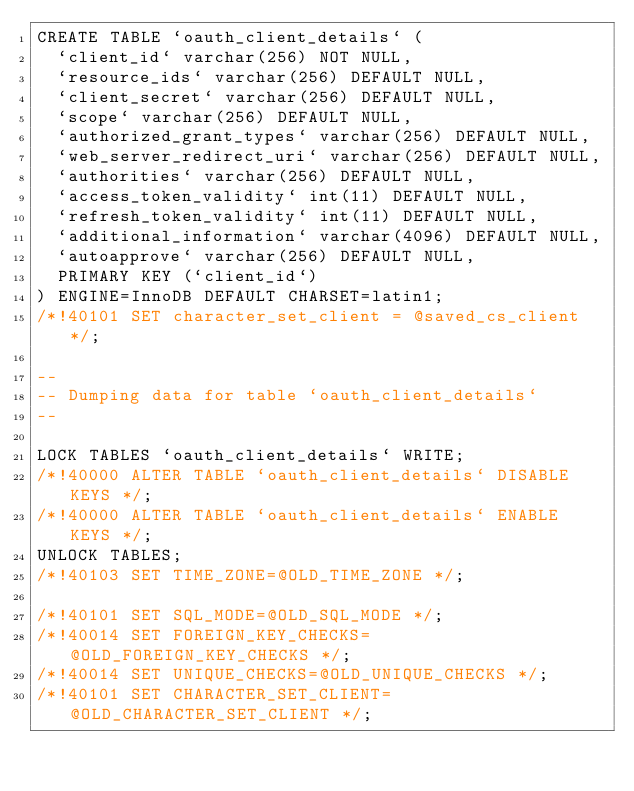Convert code to text. <code><loc_0><loc_0><loc_500><loc_500><_SQL_>CREATE TABLE `oauth_client_details` (
  `client_id` varchar(256) NOT NULL,
  `resource_ids` varchar(256) DEFAULT NULL,
  `client_secret` varchar(256) DEFAULT NULL,
  `scope` varchar(256) DEFAULT NULL,
  `authorized_grant_types` varchar(256) DEFAULT NULL,
  `web_server_redirect_uri` varchar(256) DEFAULT NULL,
  `authorities` varchar(256) DEFAULT NULL,
  `access_token_validity` int(11) DEFAULT NULL,
  `refresh_token_validity` int(11) DEFAULT NULL,
  `additional_information` varchar(4096) DEFAULT NULL,
  `autoapprove` varchar(256) DEFAULT NULL,
  PRIMARY KEY (`client_id`)
) ENGINE=InnoDB DEFAULT CHARSET=latin1;
/*!40101 SET character_set_client = @saved_cs_client */;

--
-- Dumping data for table `oauth_client_details`
--

LOCK TABLES `oauth_client_details` WRITE;
/*!40000 ALTER TABLE `oauth_client_details` DISABLE KEYS */;
/*!40000 ALTER TABLE `oauth_client_details` ENABLE KEYS */;
UNLOCK TABLES;
/*!40103 SET TIME_ZONE=@OLD_TIME_ZONE */;

/*!40101 SET SQL_MODE=@OLD_SQL_MODE */;
/*!40014 SET FOREIGN_KEY_CHECKS=@OLD_FOREIGN_KEY_CHECKS */;
/*!40014 SET UNIQUE_CHECKS=@OLD_UNIQUE_CHECKS */;
/*!40101 SET CHARACTER_SET_CLIENT=@OLD_CHARACTER_SET_CLIENT */;</code> 